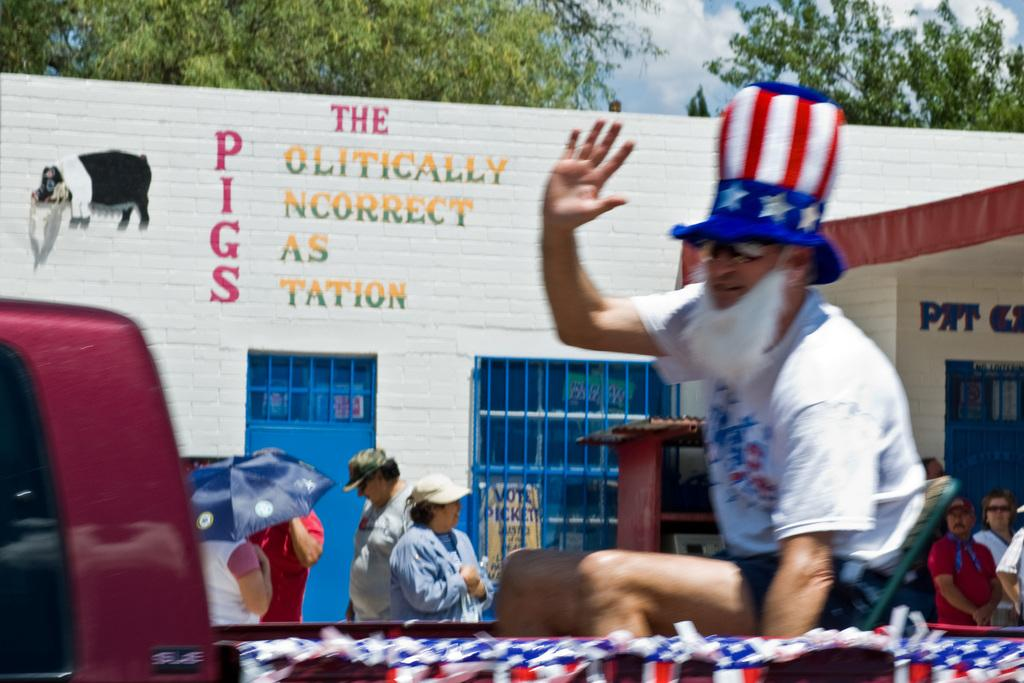<image>
Create a compact narrative representing the image presented. A man in an Uncle Sam hat outside of a gas station 